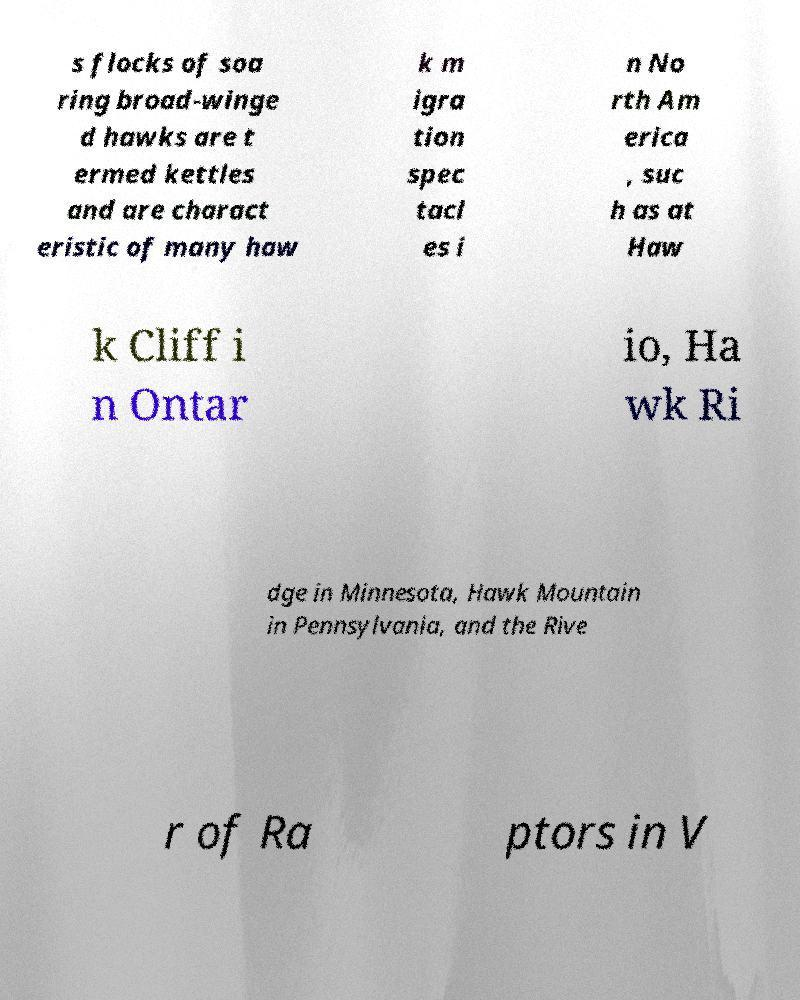Can you read and provide the text displayed in the image?This photo seems to have some interesting text. Can you extract and type it out for me? s flocks of soa ring broad-winge d hawks are t ermed kettles and are charact eristic of many haw k m igra tion spec tacl es i n No rth Am erica , suc h as at Haw k Cliff i n Ontar io, Ha wk Ri dge in Minnesota, Hawk Mountain in Pennsylvania, and the Rive r of Ra ptors in V 